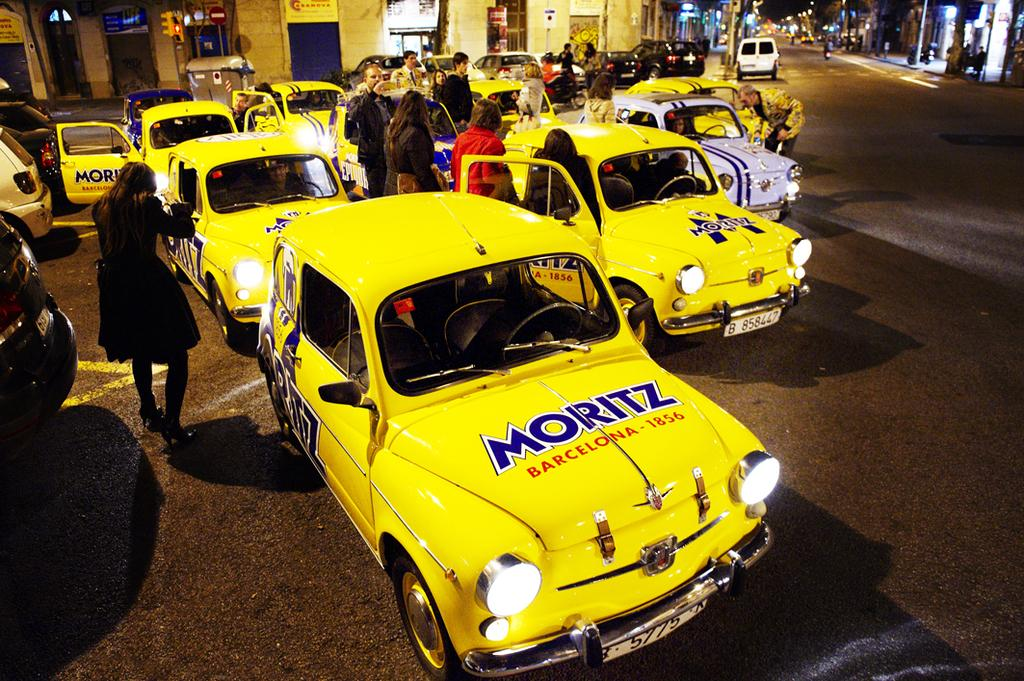Provide a one-sentence caption for the provided image. A fleet of bright yeallow classic cars are being looked at by people, the nearest bears the words Moritz and Barecelona 1856 on its bonnet. 